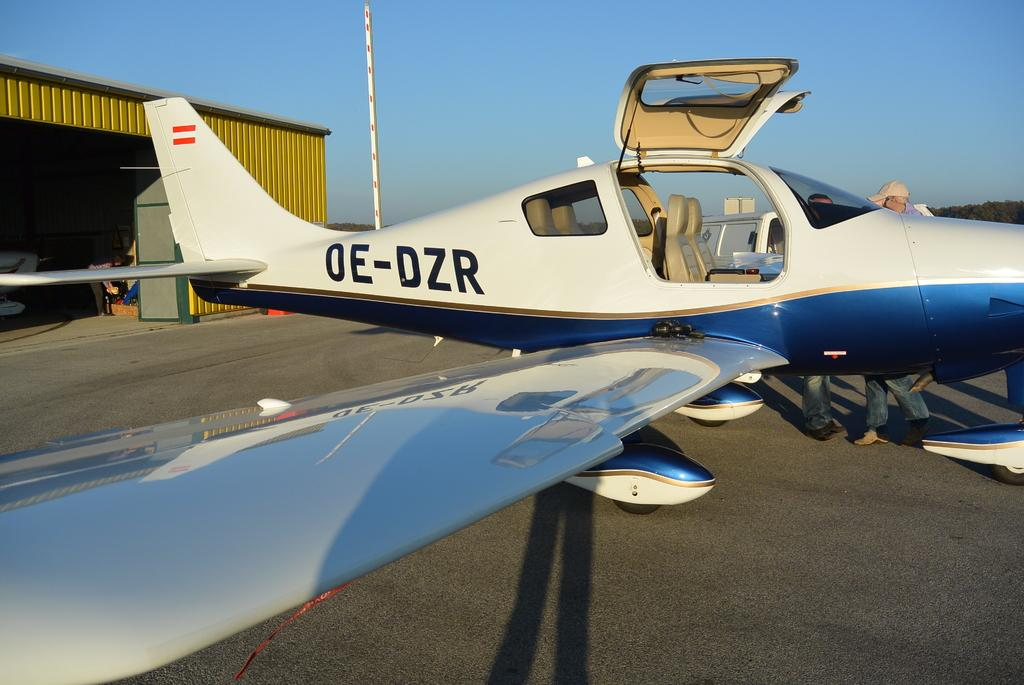<image>
Summarize the visual content of the image. A small plane outside of a hanger labeled OE-DZR. 